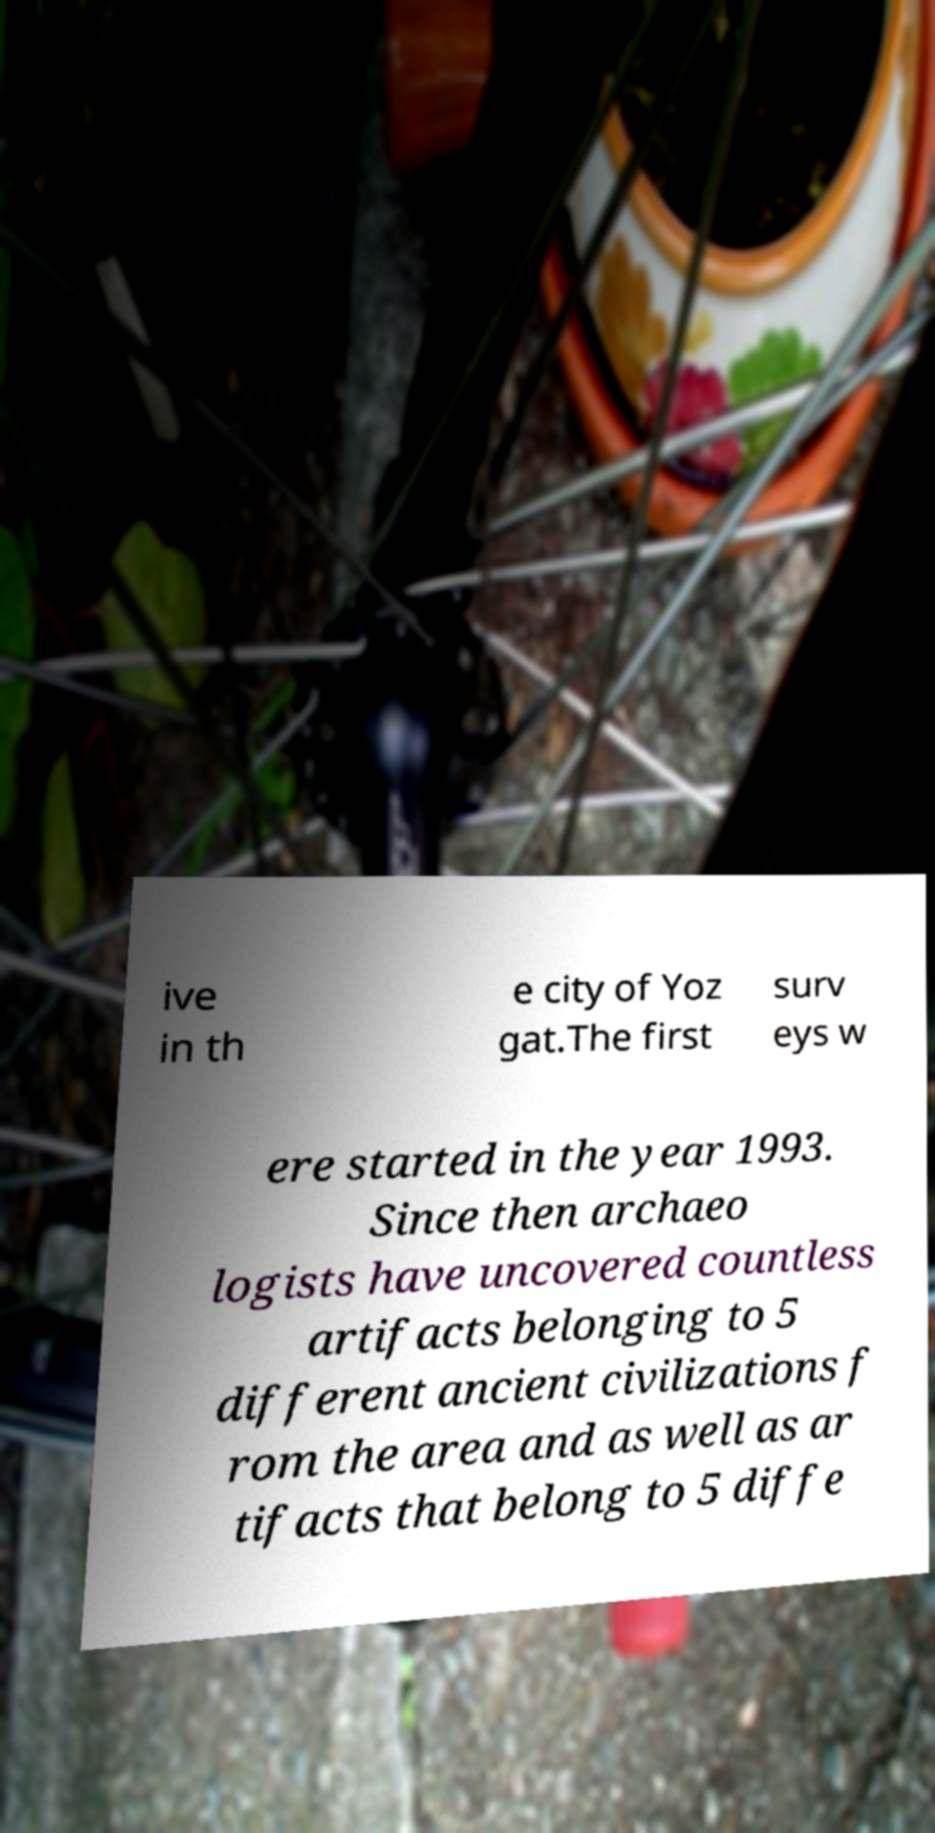I need the written content from this picture converted into text. Can you do that? ive in th e city of Yoz gat.The first surv eys w ere started in the year 1993. Since then archaeo logists have uncovered countless artifacts belonging to 5 different ancient civilizations f rom the area and as well as ar tifacts that belong to 5 diffe 